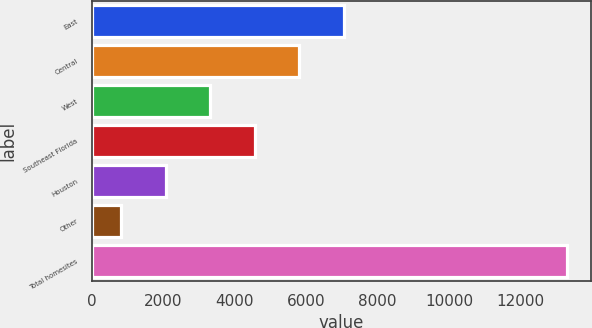Convert chart to OTSL. <chart><loc_0><loc_0><loc_500><loc_500><bar_chart><fcel>East<fcel>Central<fcel>West<fcel>Southeast Florida<fcel>Houston<fcel>Other<fcel>Total homesites<nl><fcel>7060<fcel>5809.6<fcel>3308.8<fcel>4559.2<fcel>2058.4<fcel>808<fcel>13312<nl></chart> 